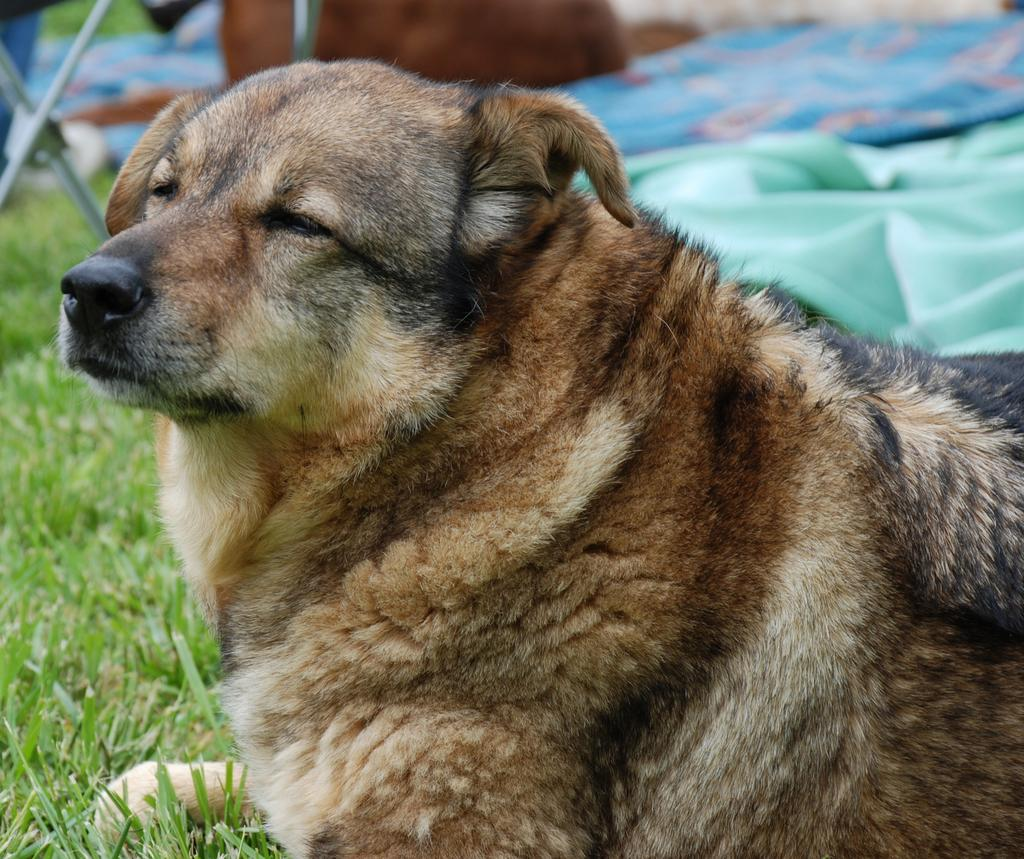What is the main subject in the center of the image? There is a dog in the center of the image. What is the dog standing on? The dog is on the grass. What can be seen in the background of the image? There is a person, tents, and a stand in the background of the image. What type of camera is the dog using to take pictures in the image? There is no camera present in the image, and the dog is not taking pictures. 